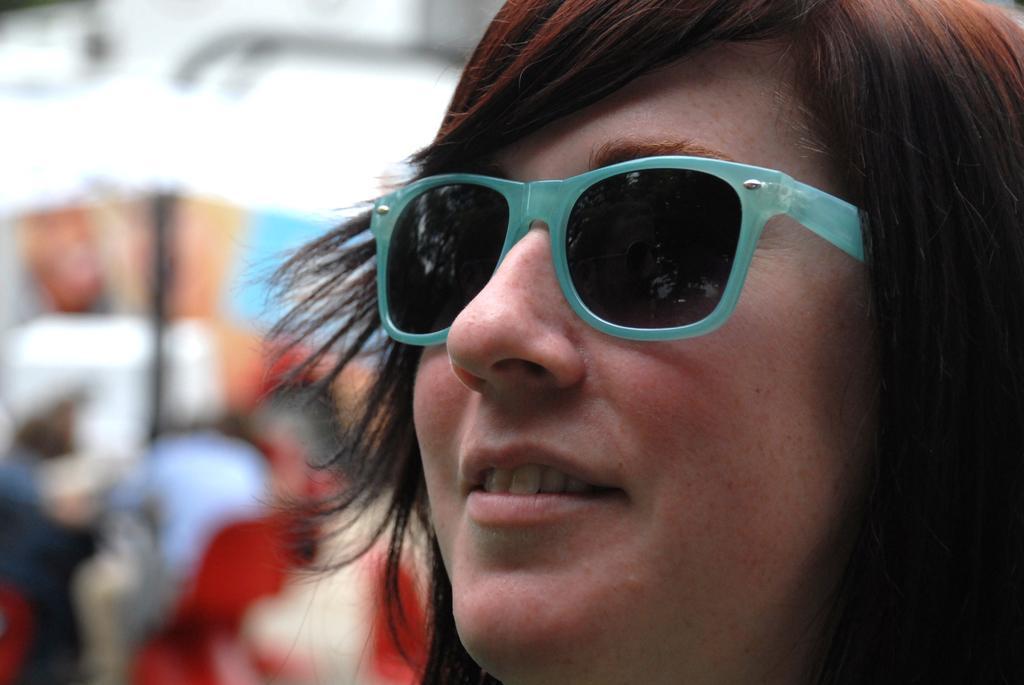Could you give a brief overview of what you see in this image? In this picture we can see a person with the goggles and behind the person there is a blurred background. 